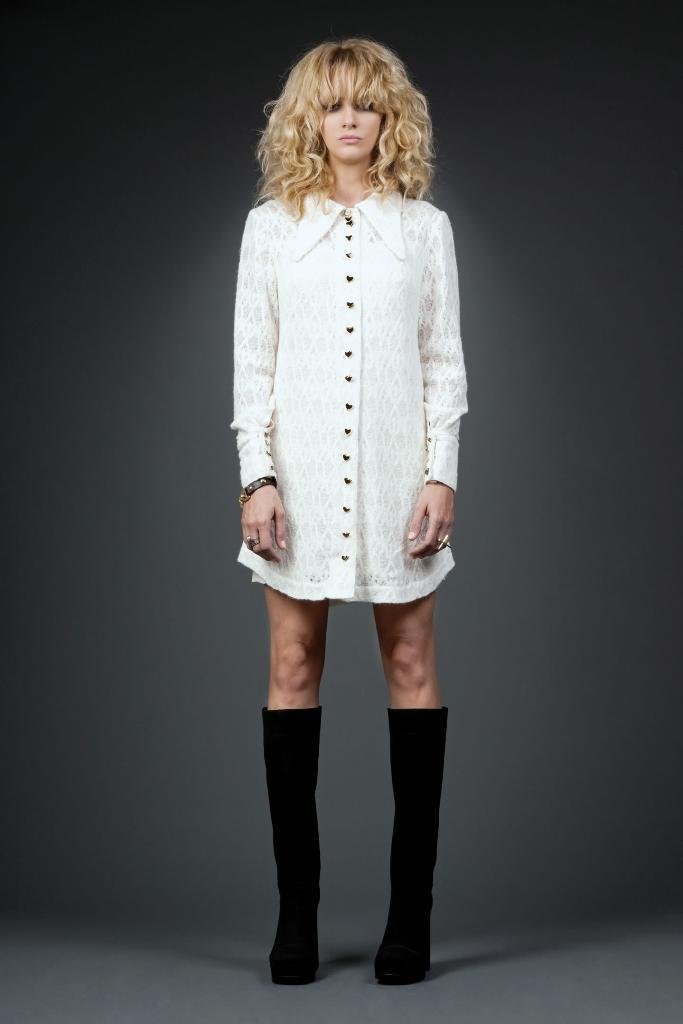In one or two sentences, can you explain what this image depicts? In this image we can see a lady, and the background is gray in color. 